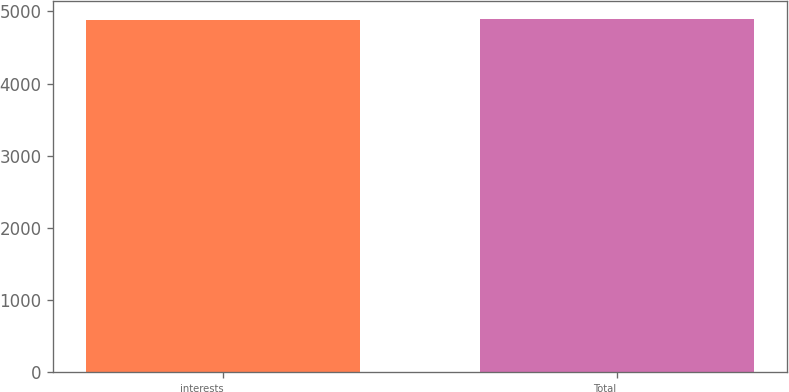<chart> <loc_0><loc_0><loc_500><loc_500><bar_chart><fcel>interests<fcel>Total<nl><fcel>4877<fcel>4895<nl></chart> 